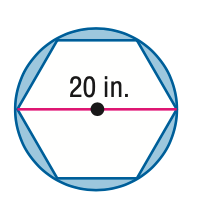Question: Find the area of the shaded region. Assume that all polygons that appear to be regular are regular. Round to the nearest tenth.
Choices:
A. 54.4
B. 97.6
C. 108.8
D. 184.2
Answer with the letter. Answer: A 